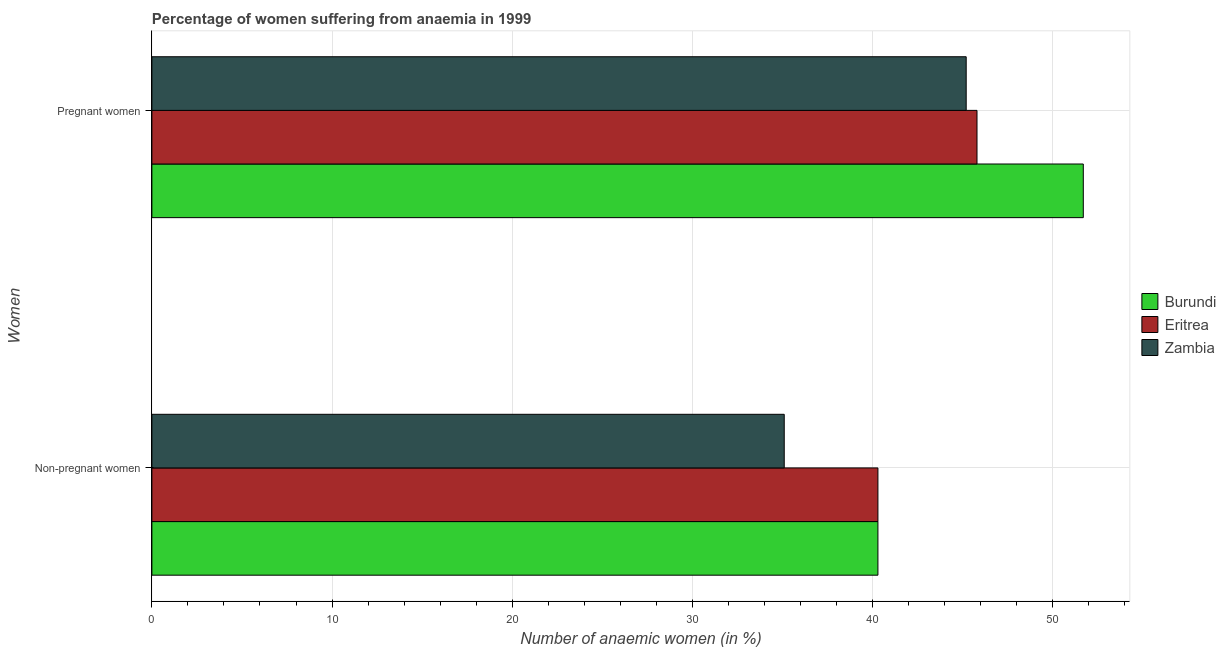How many different coloured bars are there?
Make the answer very short. 3. How many groups of bars are there?
Make the answer very short. 2. How many bars are there on the 2nd tick from the bottom?
Your response must be concise. 3. What is the label of the 2nd group of bars from the top?
Ensure brevity in your answer.  Non-pregnant women. What is the percentage of pregnant anaemic women in Zambia?
Keep it short and to the point. 45.2. Across all countries, what is the maximum percentage of pregnant anaemic women?
Give a very brief answer. 51.7. Across all countries, what is the minimum percentage of pregnant anaemic women?
Offer a very short reply. 45.2. In which country was the percentage of pregnant anaemic women maximum?
Your answer should be compact. Burundi. In which country was the percentage of pregnant anaemic women minimum?
Offer a very short reply. Zambia. What is the total percentage of non-pregnant anaemic women in the graph?
Provide a short and direct response. 115.7. What is the average percentage of pregnant anaemic women per country?
Your answer should be very brief. 47.57. What is the difference between the percentage of non-pregnant anaemic women and percentage of pregnant anaemic women in Zambia?
Provide a short and direct response. -10.1. Is the percentage of non-pregnant anaemic women in Burundi less than that in Zambia?
Make the answer very short. No. What does the 1st bar from the top in Non-pregnant women represents?
Offer a terse response. Zambia. What does the 3rd bar from the bottom in Pregnant women represents?
Provide a short and direct response. Zambia. Are all the bars in the graph horizontal?
Your response must be concise. Yes. What is the difference between two consecutive major ticks on the X-axis?
Ensure brevity in your answer.  10. Are the values on the major ticks of X-axis written in scientific E-notation?
Make the answer very short. No. Does the graph contain any zero values?
Your answer should be compact. No. Does the graph contain grids?
Your response must be concise. Yes. Where does the legend appear in the graph?
Provide a short and direct response. Center right. What is the title of the graph?
Offer a very short reply. Percentage of women suffering from anaemia in 1999. Does "Benin" appear as one of the legend labels in the graph?
Make the answer very short. No. What is the label or title of the X-axis?
Keep it short and to the point. Number of anaemic women (in %). What is the label or title of the Y-axis?
Your response must be concise. Women. What is the Number of anaemic women (in %) in Burundi in Non-pregnant women?
Provide a succinct answer. 40.3. What is the Number of anaemic women (in %) in Eritrea in Non-pregnant women?
Your answer should be very brief. 40.3. What is the Number of anaemic women (in %) of Zambia in Non-pregnant women?
Offer a terse response. 35.1. What is the Number of anaemic women (in %) of Burundi in Pregnant women?
Make the answer very short. 51.7. What is the Number of anaemic women (in %) in Eritrea in Pregnant women?
Your answer should be compact. 45.8. What is the Number of anaemic women (in %) of Zambia in Pregnant women?
Provide a short and direct response. 45.2. Across all Women, what is the maximum Number of anaemic women (in %) of Burundi?
Make the answer very short. 51.7. Across all Women, what is the maximum Number of anaemic women (in %) in Eritrea?
Keep it short and to the point. 45.8. Across all Women, what is the maximum Number of anaemic women (in %) of Zambia?
Keep it short and to the point. 45.2. Across all Women, what is the minimum Number of anaemic women (in %) in Burundi?
Keep it short and to the point. 40.3. Across all Women, what is the minimum Number of anaemic women (in %) of Eritrea?
Give a very brief answer. 40.3. Across all Women, what is the minimum Number of anaemic women (in %) in Zambia?
Your response must be concise. 35.1. What is the total Number of anaemic women (in %) of Burundi in the graph?
Offer a very short reply. 92. What is the total Number of anaemic women (in %) in Eritrea in the graph?
Your response must be concise. 86.1. What is the total Number of anaemic women (in %) in Zambia in the graph?
Your response must be concise. 80.3. What is the difference between the Number of anaemic women (in %) in Eritrea in Non-pregnant women and that in Pregnant women?
Give a very brief answer. -5.5. What is the difference between the Number of anaemic women (in %) of Zambia in Non-pregnant women and that in Pregnant women?
Give a very brief answer. -10.1. What is the difference between the Number of anaemic women (in %) of Burundi in Non-pregnant women and the Number of anaemic women (in %) of Eritrea in Pregnant women?
Provide a short and direct response. -5.5. What is the difference between the Number of anaemic women (in %) of Burundi in Non-pregnant women and the Number of anaemic women (in %) of Zambia in Pregnant women?
Provide a short and direct response. -4.9. What is the average Number of anaemic women (in %) in Burundi per Women?
Your response must be concise. 46. What is the average Number of anaemic women (in %) of Eritrea per Women?
Keep it short and to the point. 43.05. What is the average Number of anaemic women (in %) in Zambia per Women?
Your response must be concise. 40.15. What is the difference between the Number of anaemic women (in %) in Burundi and Number of anaemic women (in %) in Eritrea in Non-pregnant women?
Your response must be concise. 0. What is the difference between the Number of anaemic women (in %) of Eritrea and Number of anaemic women (in %) of Zambia in Non-pregnant women?
Make the answer very short. 5.2. What is the difference between the Number of anaemic women (in %) in Burundi and Number of anaemic women (in %) in Eritrea in Pregnant women?
Keep it short and to the point. 5.9. What is the difference between the Number of anaemic women (in %) of Burundi and Number of anaemic women (in %) of Zambia in Pregnant women?
Provide a succinct answer. 6.5. What is the difference between the Number of anaemic women (in %) in Eritrea and Number of anaemic women (in %) in Zambia in Pregnant women?
Provide a succinct answer. 0.6. What is the ratio of the Number of anaemic women (in %) of Burundi in Non-pregnant women to that in Pregnant women?
Offer a terse response. 0.78. What is the ratio of the Number of anaemic women (in %) in Eritrea in Non-pregnant women to that in Pregnant women?
Your answer should be compact. 0.88. What is the ratio of the Number of anaemic women (in %) of Zambia in Non-pregnant women to that in Pregnant women?
Keep it short and to the point. 0.78. What is the difference between the highest and the second highest Number of anaemic women (in %) of Eritrea?
Your answer should be compact. 5.5. What is the difference between the highest and the second highest Number of anaemic women (in %) in Zambia?
Your answer should be compact. 10.1. 